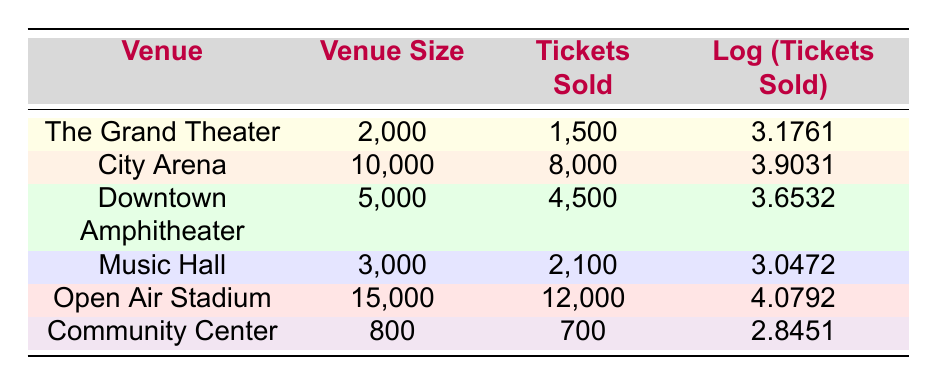What is the highest number of tickets sold at a venue? The table lists the tickets sold for each venue. The highest number is found under the "Tickets Sold" column, where "Open Air Stadium" has sold 12,000 tickets.
Answer: 12,000 Which venue had the lowest log value of tickets sold? The "Log (Tickets Sold)" column shows the logarithmic values. The lowest value is 2.8451 for the "Community Center", which indicates it had the least tickets sold on a logarithmic scale compared to others.
Answer: Community Center What is the total number of tickets sold across all venues? To find the total, I add all the values in the "Tickets Sold" column: 1500 + 8000 + 4500 + 2100 + 12000 + 700 = 30,800.
Answer: 30,800 Is it true that the tickets sold at the Downtown Amphitheater were more than half of its venue size? The Downtown Amphitheater's venue size is 5,000 and tickets sold are 4,500. Since 4,500 is greater than half of 5,000 (which is 2,500), the statement is true.
Answer: Yes What is the average number of tickets sold for the venues listed? First, I calculate the total number of tickets sold, which is 30,800. There are 6 venues, so the average is 30,800 divided by 6, which equals approximately 5,133.33.
Answer: 5,133.33 Which venue has the highest ratio of tickets sold to venue size? To find this, I calculate the ratio of tickets sold to venue size for each venue. The highest ratio is for "Open Air Stadium": 12,000 tickets sold / 15,000 venue size = 0.8, which is higher than others.
Answer: Open Air Stadium What is the log value for the tickets sold at The Grand Theater? In the table, the "Log (Tickets Sold)" for "The Grand Theater" is listed directly as 3.1761.
Answer: 3.1761 Did the City Arena sell more tickets than the music capacity of Music Hall? The City Arena sold 8,000 tickets, while the Music Hall's venue size is 3,000. Since 8,000 is greater than 3,000, the statement is true.
Answer: Yes 